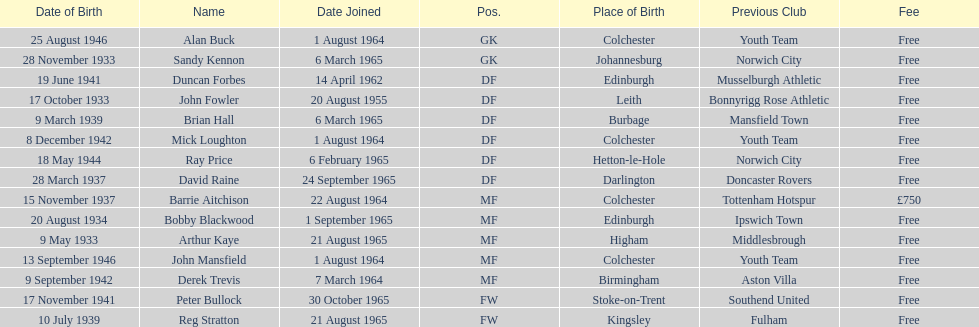Which athlete is the most aged? Arthur Kaye. 